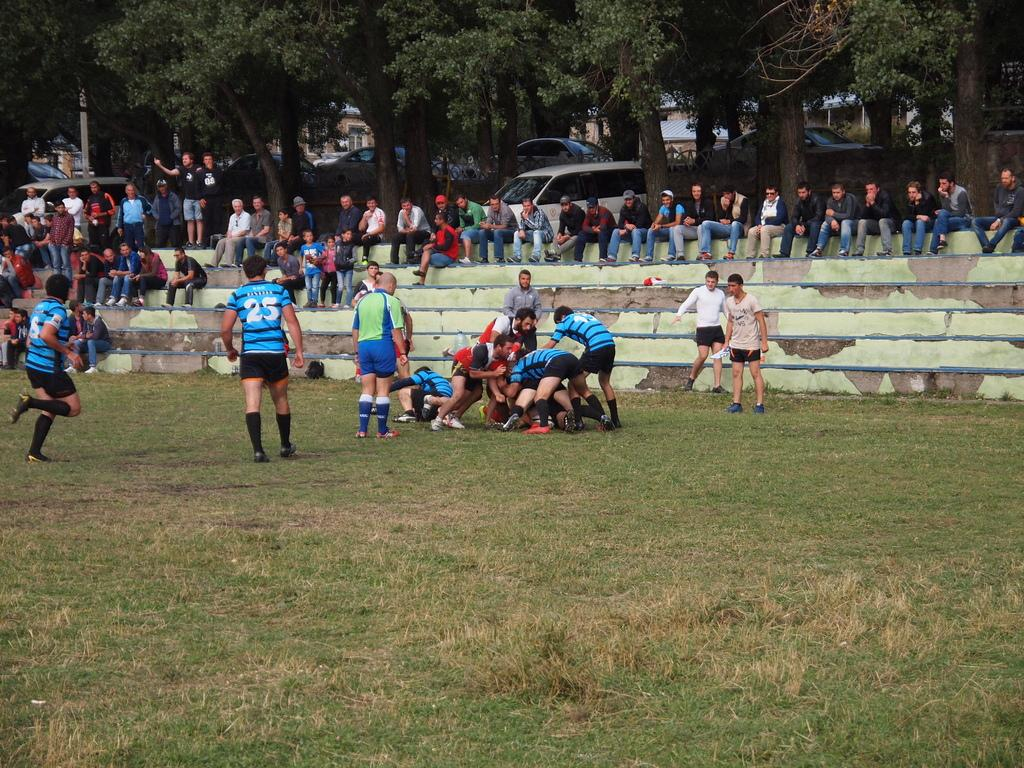How many people are present in the image? There are people in the image, but the exact number is not specified. What are some of the people doing in the image? Some people are playing on the ground, while others are sitting on the steps. What type of vegetation can be seen in the image? There are trees in the image. What else can be seen in the image besides people and trees? There are cars and houses in the image. How many dolls are sitting inside the tent in the image? There are no dolls or tents present in the image. 